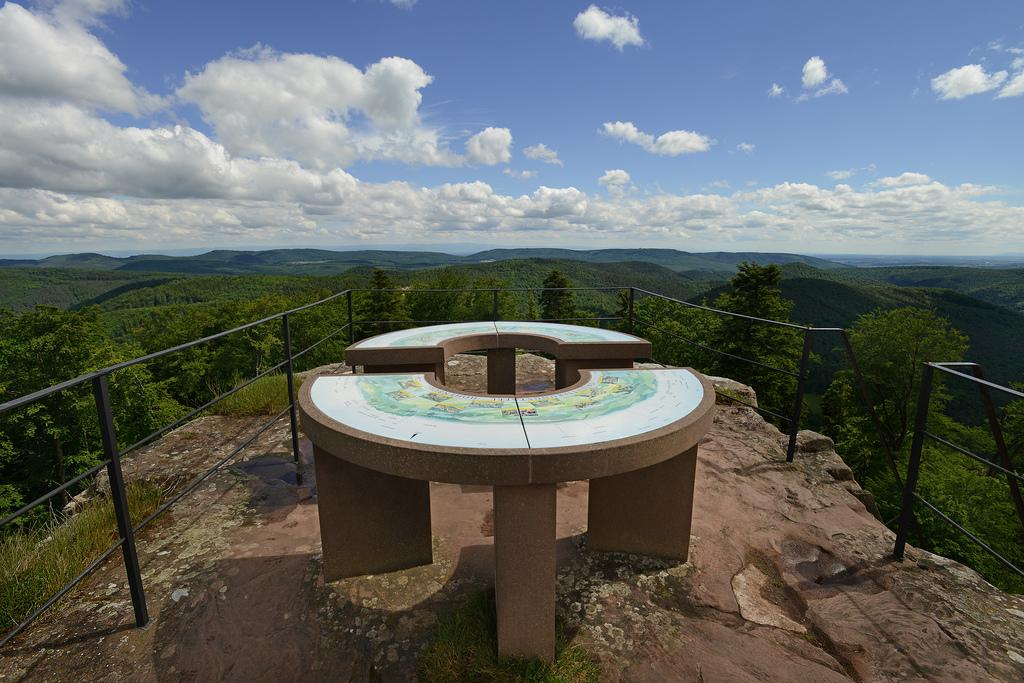What is the main subject in the middle of the image? There is a sculpture-like structure in the middle of the image. What is around the structure? The structure is surrounded by a fence. What can be seen in the background of the image? Sky, clouds, hills, and trees are present in the background of the image. What type of current is flowing through the sculpture in the image? There is no current flowing through the sculpture in the image; it is a stationary structure. Can you see any goats interacting with the sculpture in the image? There are no goats present in the image. 